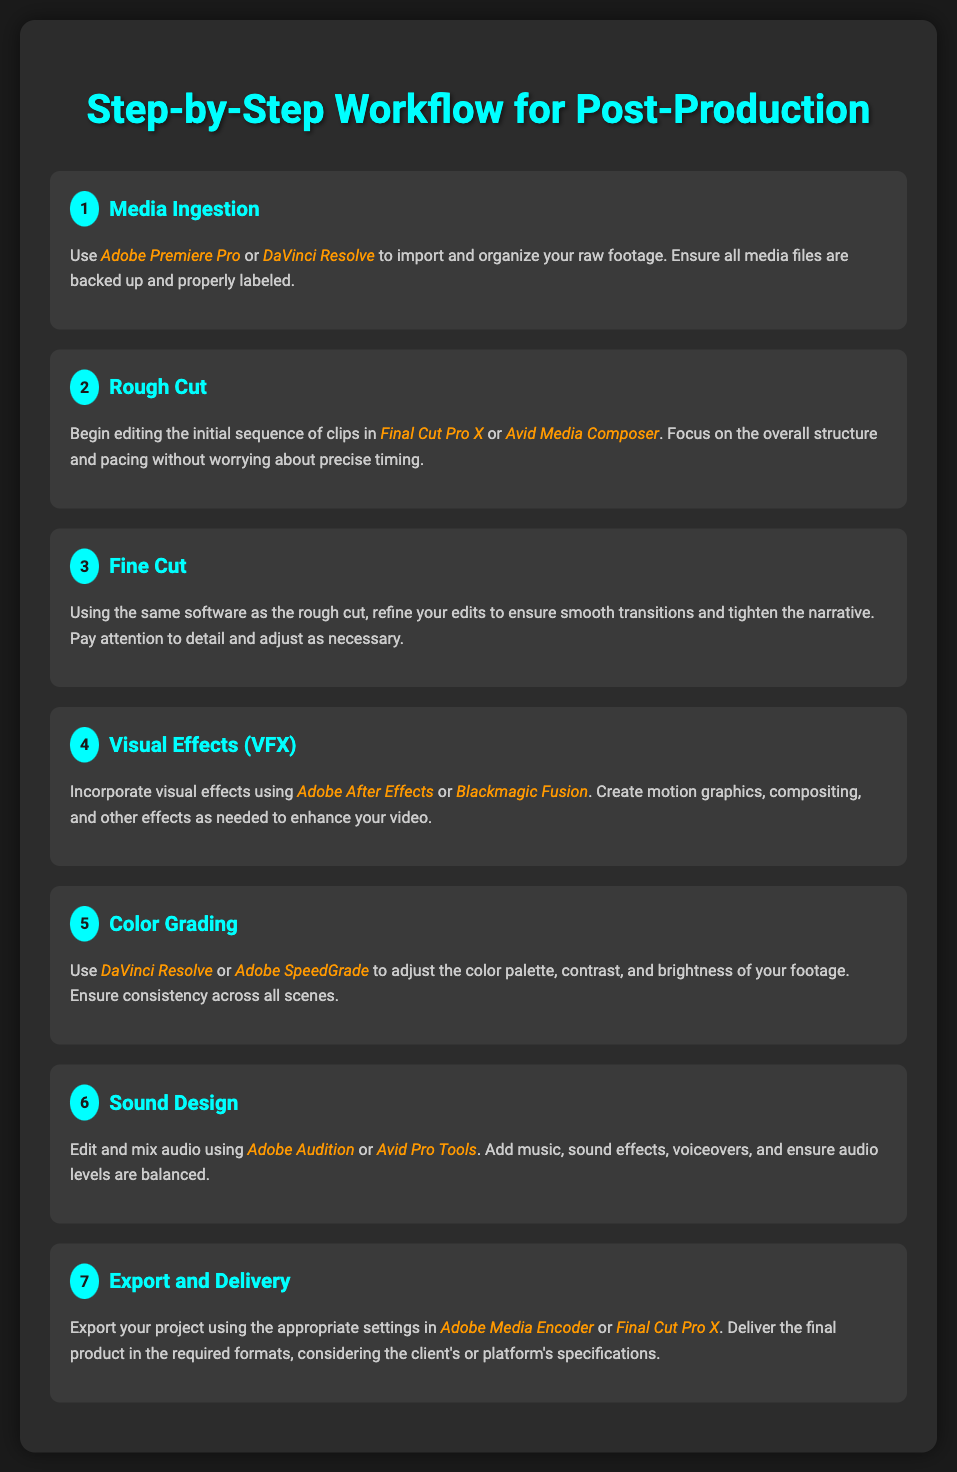What is the purpose of the "Sound Design" step? The purpose of "Sound Design" is to edit and mix audio, including adding music and sound effects.
Answer: Edit and mix audio How many steps are there in total in the post-production workflow? There are seven steps detailed in the document.
Answer: Seven Which software is used for "Color Grading"? The software recommended for "Color Grading" is either "DaVinci Resolve" or "Adobe SpeedGrade".
Answer: DaVinci Resolve or Adobe SpeedGrade What step comes after "Visual Effects (VFX)"? The step that follows "Visual Effects (VFX)" is "Color Grading".
Answer: Color Grading What is the last step in the workflow? The last step mentioned is "Export and Delivery".
Answer: Export and Delivery Which software should be used for media ingestion? The software suggested for media ingestion is either "Adobe Premiere Pro" or "DaVinci Resolve".
Answer: Adobe Premiere Pro or DaVinci Resolve 